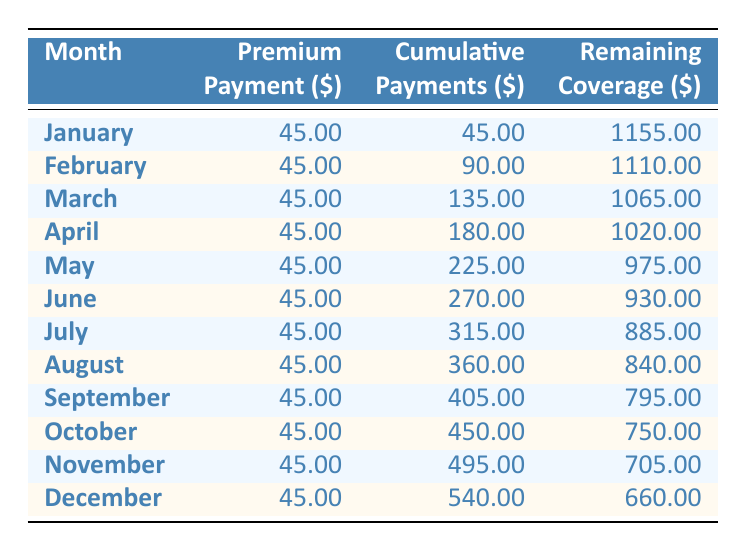What is the monthly premium payment for Oliver's pet insurance policy? The table shows that the premium payment for each month is consistently listed as 45.00 for every month from January to December.
Answer: 45.00 What is the cumulative payment by June? To find the cumulative payment by June, we can look at the cumulative payment column for June, which is listed as 270.00.
Answer: 270.00 How much remaining coverage is there after October? The remaining coverage for October is specified in the table as 750.00, so that is the amount of remaining coverage after October.
Answer: 750.00 What is the total cumulative payment for the entire year? To calculate the total cumulative payment for the entire year, we look at the last row for December, where the cumulative payments total 540.00.
Answer: 540.00 Is there any month where the premium payment is different from 45.00? According to the table, the premium payment is consistently noted as 45.00 for each month, indicating no month has a different premium payment.
Answer: No What is the change in remaining coverage from January to December? To find the change in remaining coverage, we take the remaining coverage in January (1155.00) and subtract the remaining coverage in December (660.00). This results in a change of 495.00 (1155.00 - 660.00).
Answer: 495.00 What is the average remaining coverage for the first half of the year (January to June)? To find the average remaining coverage for January through June, we sum up the remaining coverage for those months: 1155.00 (Jan) + 1110.00 (Feb) + 1065.00 (Mar) + 1020.00 (Apr) + 975.00 (May) + 930.00 (Jun) = 6265.00. There are 6 months, thus the average remaining coverage is 6265.00 ÷ 6 = 1044.17.
Answer: 1044.17 Which month had the least remaining coverage? By examining the remaining coverage column, we see that December has the lowest remaining value at 660.00, indicating it had the least remaining coverage for the year.
Answer: December How much did the cumulative payments increase from July to December? The cumulative payment in July is 315.00 and in December it is 540.00. To find the increase, we subtract the July total from December's total: 540.00 - 315.00 = 225.00.
Answer: 225.00 